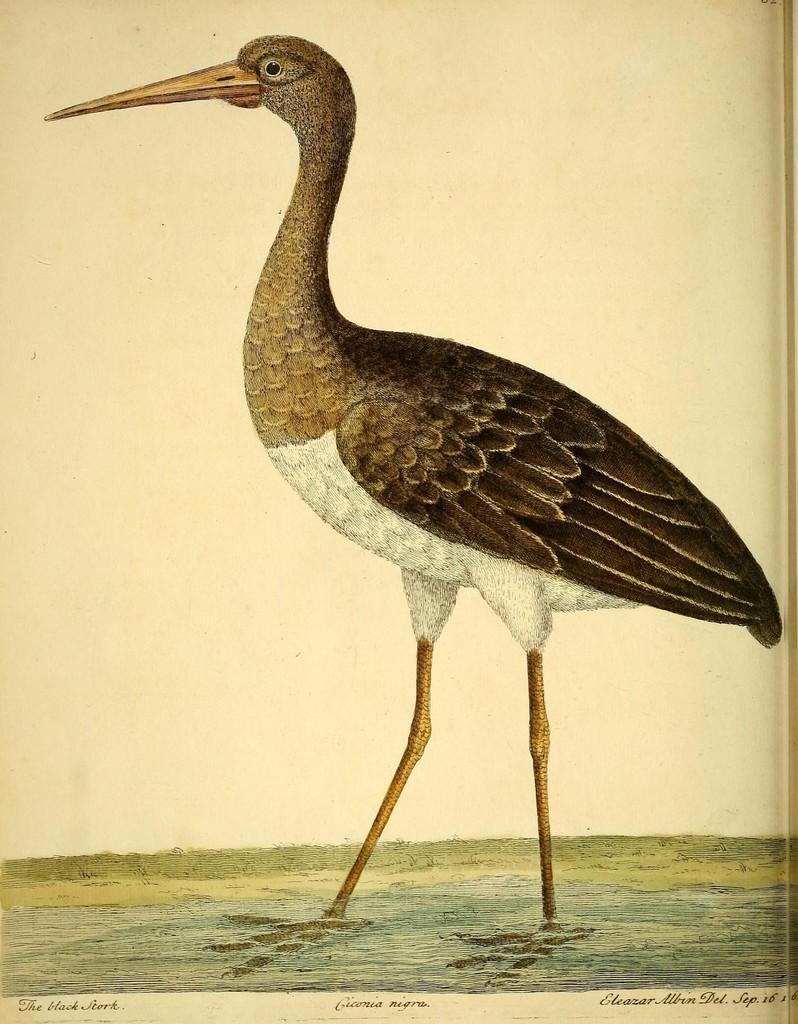Describe this image in one or two sentences. This image contains painting. A bird is standing in water. Bottom of the image there is some text. 